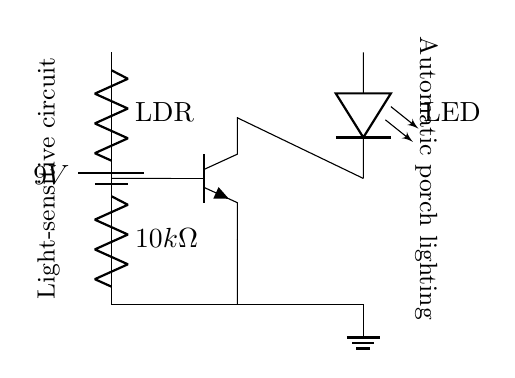What component is used to detect light? The light-dependent resistor (LDR) is the component used to detect light. It changes its resistance according to the light intensity and is part of the voltage divider in the circuit.
Answer: LDR What is the value of the resistor in this circuit? The resistor value is ten kilohms, as indicated in the diagram next to the resistor symbol.
Answer: 10k ohms What type of transistor is used in the circuit? The circuit uses an NPN transistor, which can be identified by the labeling in the diagram and its orientation within the circuit.
Answer: NPN What is the function of the LED in this circuit? The LED serves as an output indicator that lights up when the circuit is activated by the dark conditions detected by the LDR.
Answer: Output indicator What happens to the LED when the light level decreases? When the light level decreases, the resistance of the LDR increases, causing the transistor to conduct and turn on the LED, illuminating it in response to low light.
Answer: LED lights up What is the purpose of the voltage divider in this circuit? The voltage divider, consisting of the LDR and the resistor, creates a varying voltage depending on the light intensity, which is used to control the transistor's base and ultimately the LED.
Answer: Control transistor 